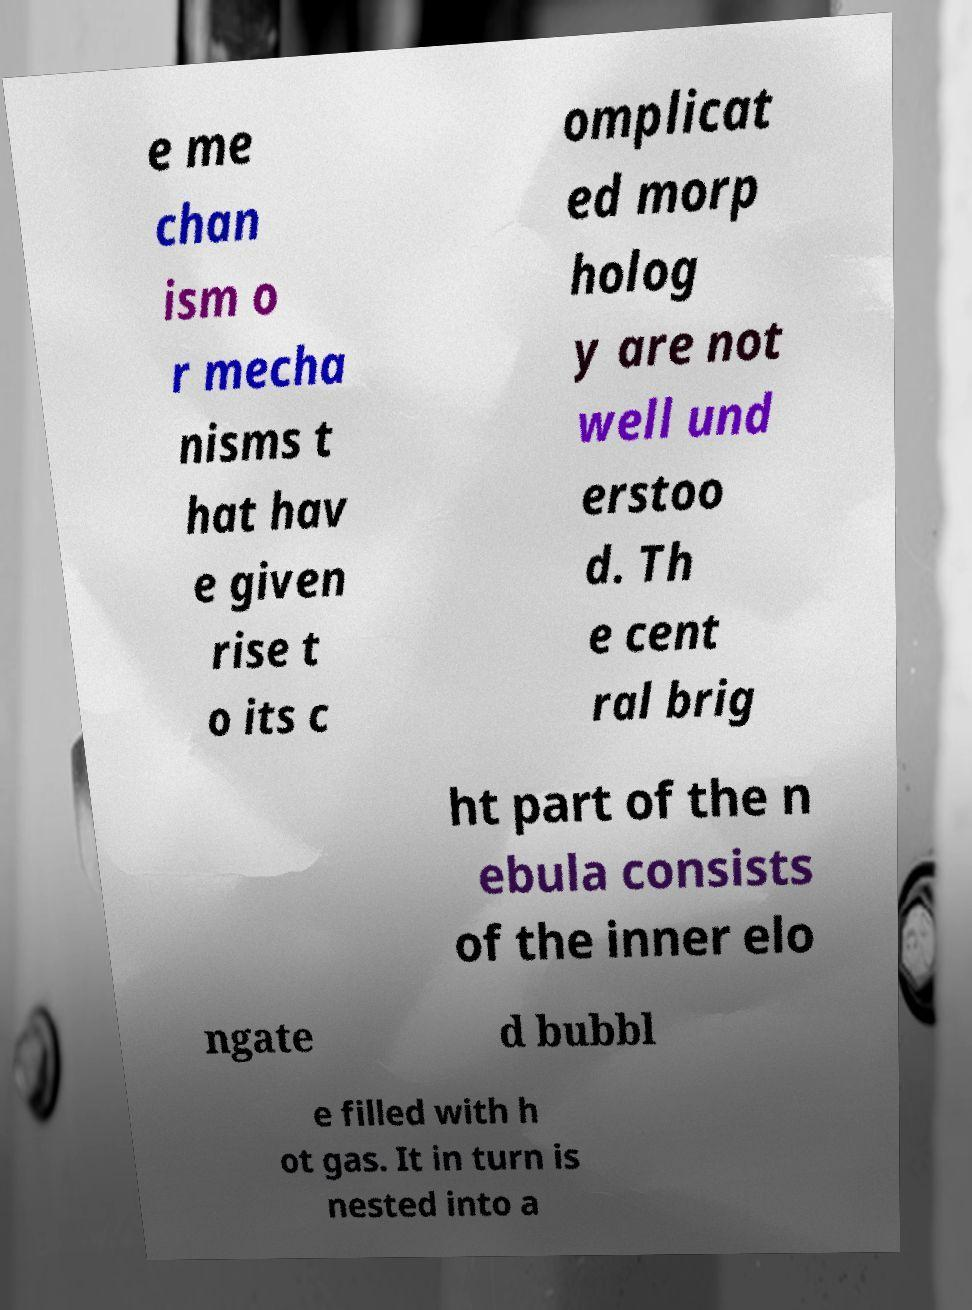Please read and relay the text visible in this image. What does it say? e me chan ism o r mecha nisms t hat hav e given rise t o its c omplicat ed morp holog y are not well und erstoo d. Th e cent ral brig ht part of the n ebula consists of the inner elo ngate d bubbl e filled with h ot gas. It in turn is nested into a 